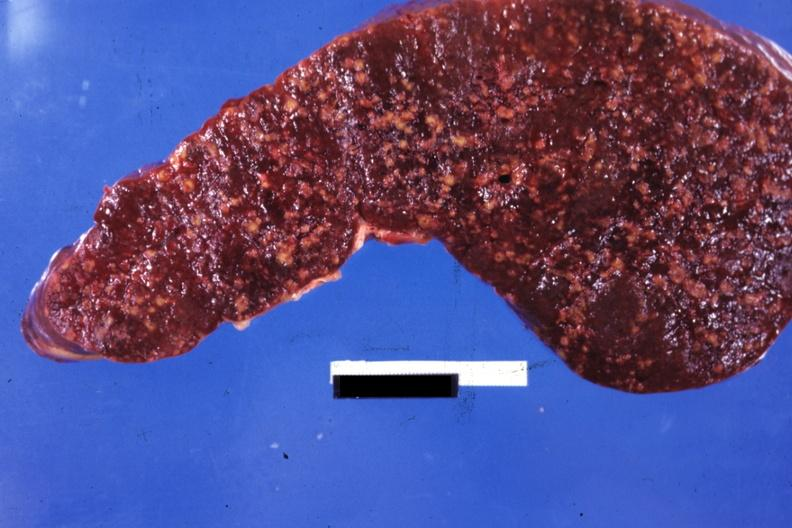what is present?
Answer the question using a single word or phrase. Spleen 